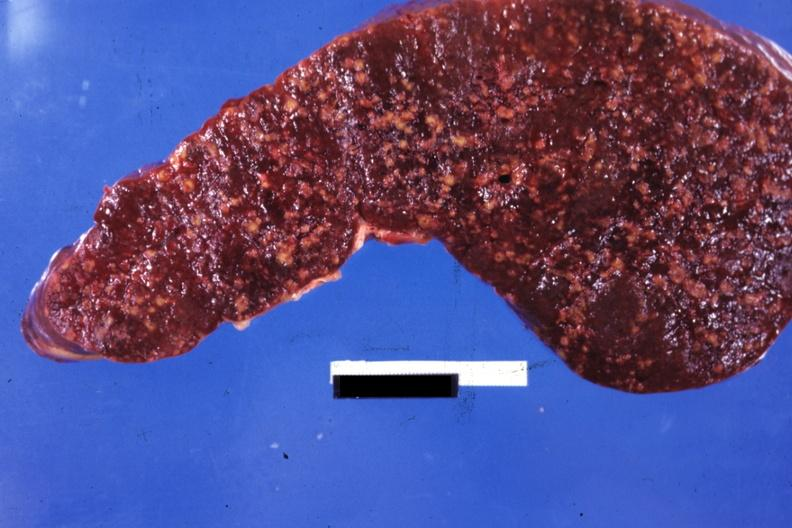what is present?
Answer the question using a single word or phrase. Spleen 